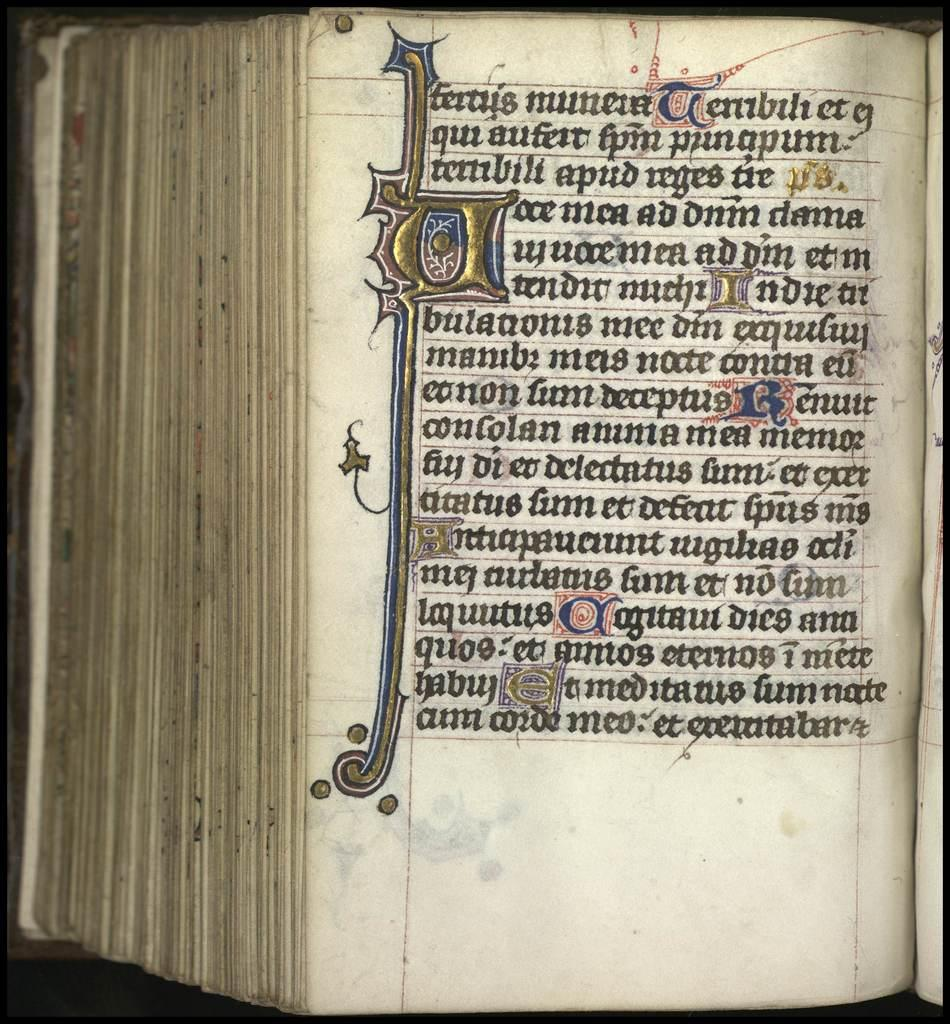Provide a one-sentence caption for the provided image. the rare book which has a traditional style of English writings with the attractive designed letter P in the left side. 